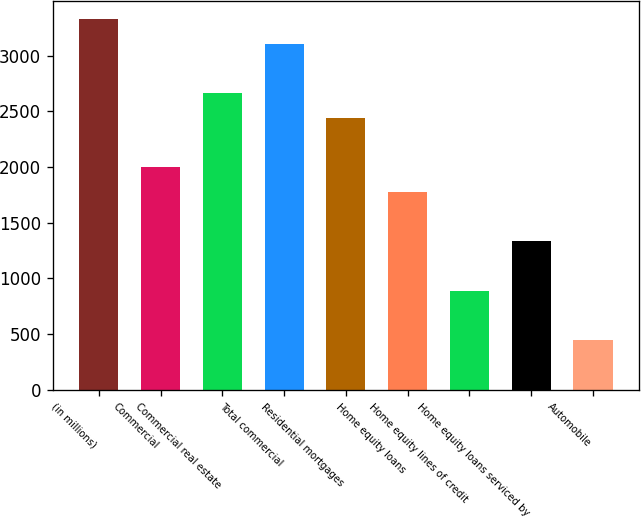Convert chart. <chart><loc_0><loc_0><loc_500><loc_500><bar_chart><fcel>(in millions)<fcel>Commercial<fcel>Commercial real estate<fcel>Total commercial<fcel>Residential mortgages<fcel>Home equity loans<fcel>Home equity lines of credit<fcel>Home equity loans serviced by<fcel>Automobile<nl><fcel>3328<fcel>1998.4<fcel>2663.2<fcel>3106.4<fcel>2441.6<fcel>1776.8<fcel>890.4<fcel>1333.6<fcel>447.2<nl></chart> 